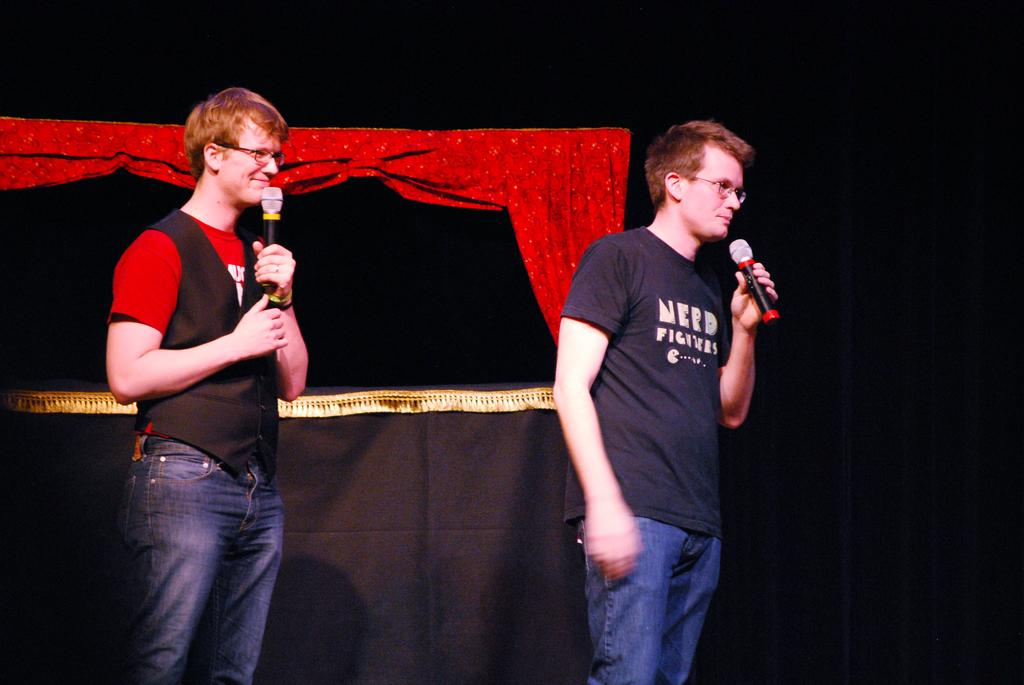How many people are in the image? There are two persons in the image. What are the two persons holding? The two persons are holding a mic. What type of leg is visible in the image? There is no leg visible in the image; it only shows two persons holding a mic. 